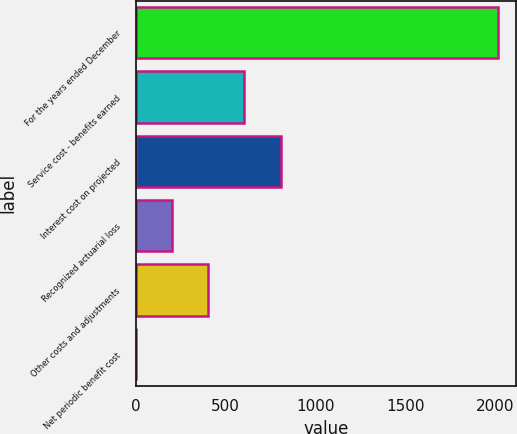Convert chart. <chart><loc_0><loc_0><loc_500><loc_500><bar_chart><fcel>For the years ended December<fcel>Service cost - benefits earned<fcel>Interest cost on projected<fcel>Recognized actuarial loss<fcel>Other costs and adjustments<fcel>Net periodic benefit cost<nl><fcel>2014<fcel>604.9<fcel>806.2<fcel>202.3<fcel>403.6<fcel>1<nl></chart> 